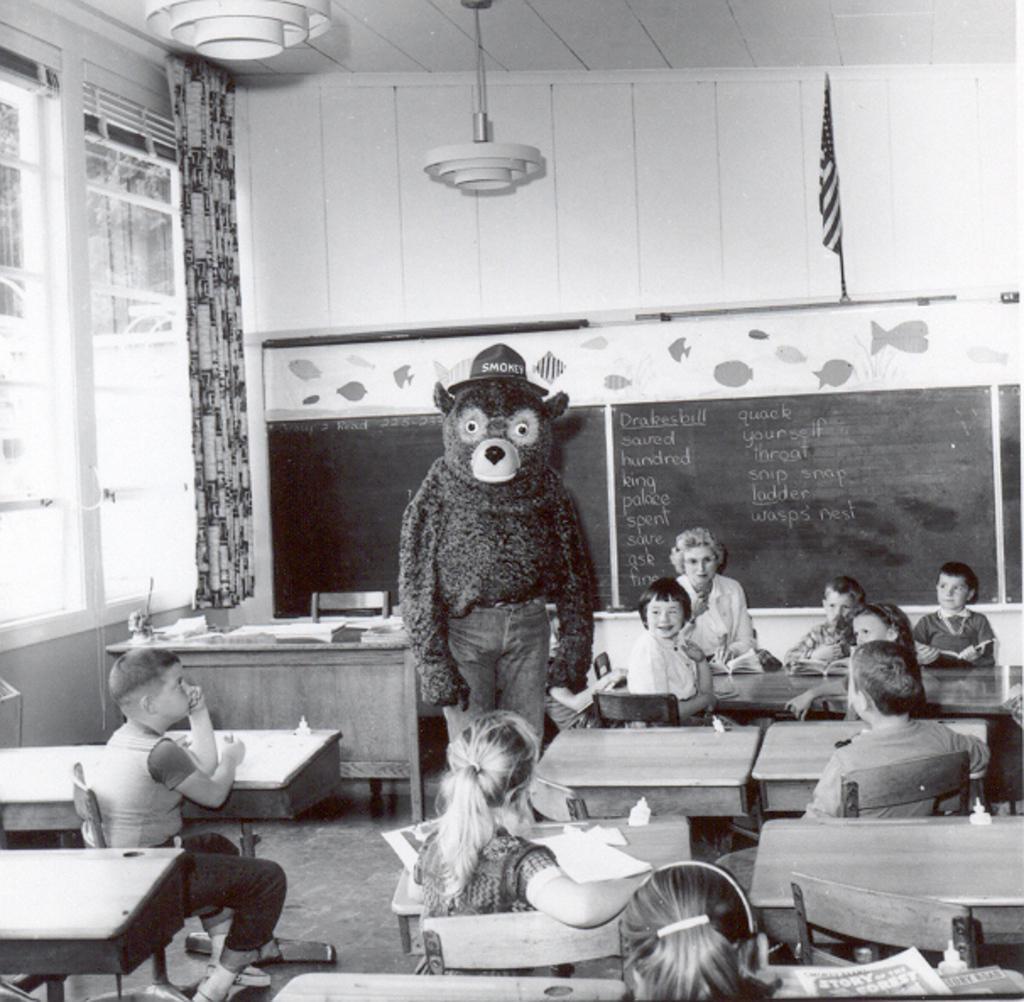Can you describe this image briefly? In this image i can see few children on chair, at the back ground i can see a woman sitting, a person standing, a table ,a chair, a board ,a flag, at left there is a curtain and a window. 